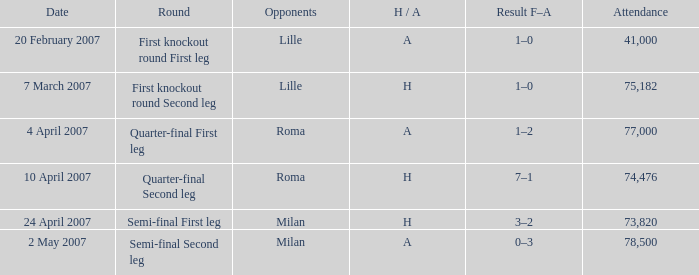On may 2, 2007, how many individuals were present? 78500.0. 